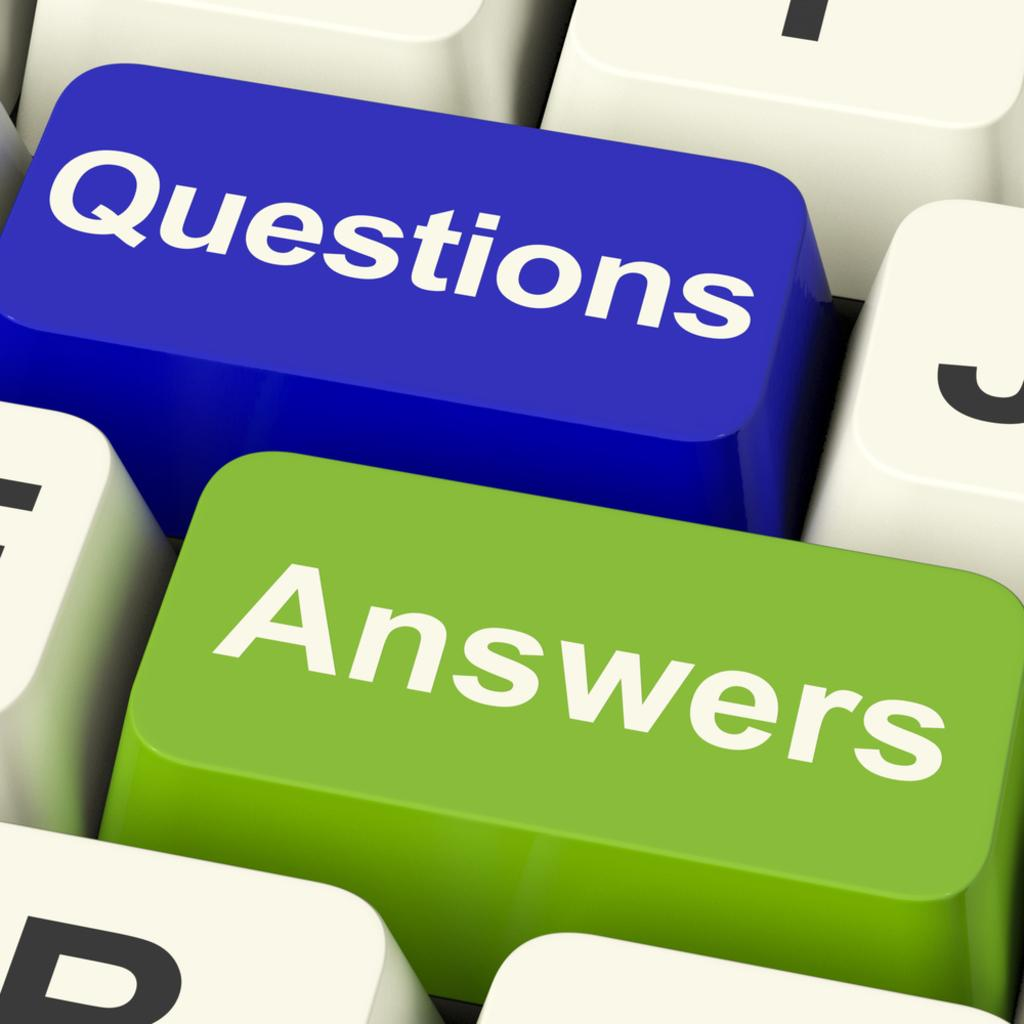<image>
Render a clear and concise summary of the photo. A blue keyboard key says questions while a green key says answers. 